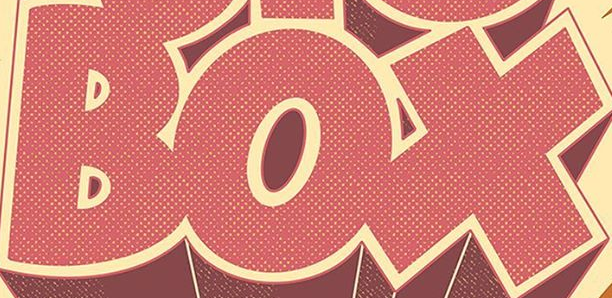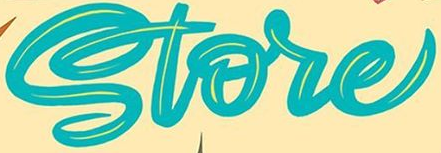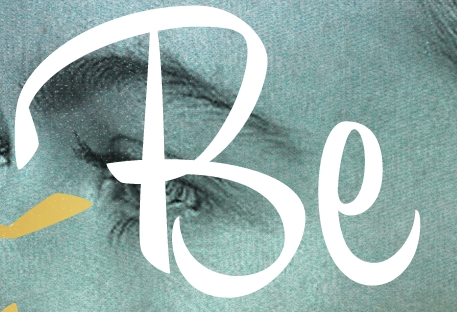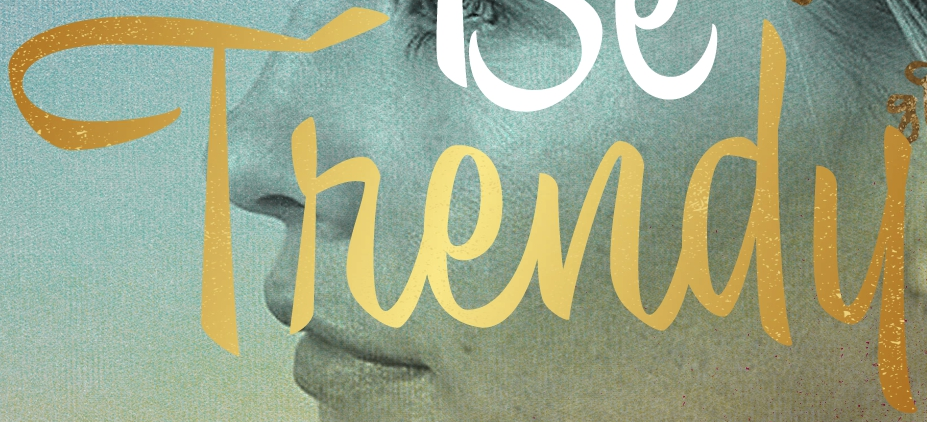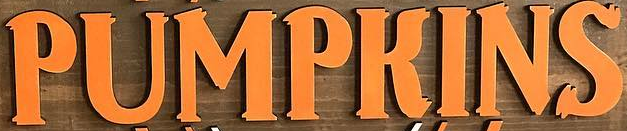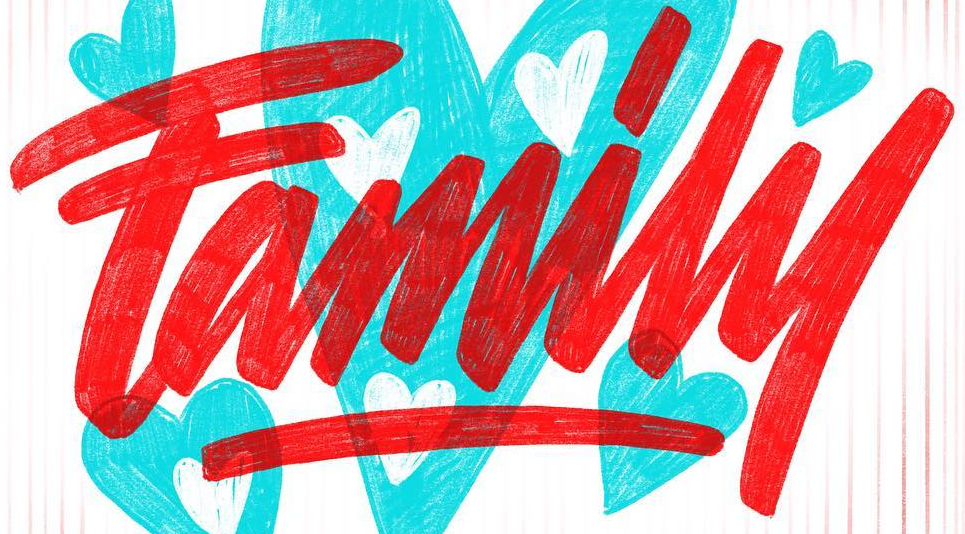What words can you see in these images in sequence, separated by a semicolon? BOX; Store; Be; Thendu; PUMPKINS; Family 